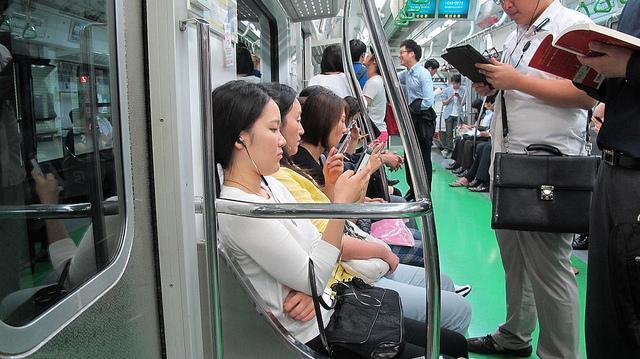How many handbags can be seen?
Give a very brief answer. 2. How many people are in the photo?
Give a very brief answer. 8. How many benches are there?
Give a very brief answer. 0. 